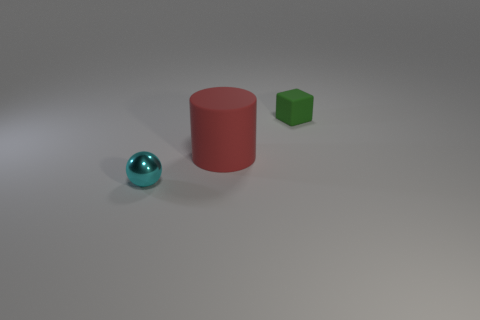There is a small thing that is in front of the small rubber object; what material is it?
Give a very brief answer. Metal. There is a thing that is in front of the rubber object that is in front of the green object that is behind the big matte cylinder; what shape is it?
Offer a very short reply. Sphere. Are there more cyan metallic spheres in front of the small green object than tiny blue metallic balls?
Provide a short and direct response. Yes. There is a small object in front of the small thing that is behind the large red rubber thing; how many big cylinders are in front of it?
Ensure brevity in your answer.  0. The object that is the same size as the rubber block is what color?
Give a very brief answer. Cyan. There is a object to the left of the matte thing in front of the tiny green block; what is its size?
Your answer should be compact. Small. How many other objects are the same size as the red matte cylinder?
Provide a succinct answer. 0. How many green rubber things are there?
Offer a very short reply. 1. Is the size of the rubber cylinder the same as the green thing?
Your answer should be very brief. No. How many other things are there of the same shape as the large red rubber object?
Offer a terse response. 0. 